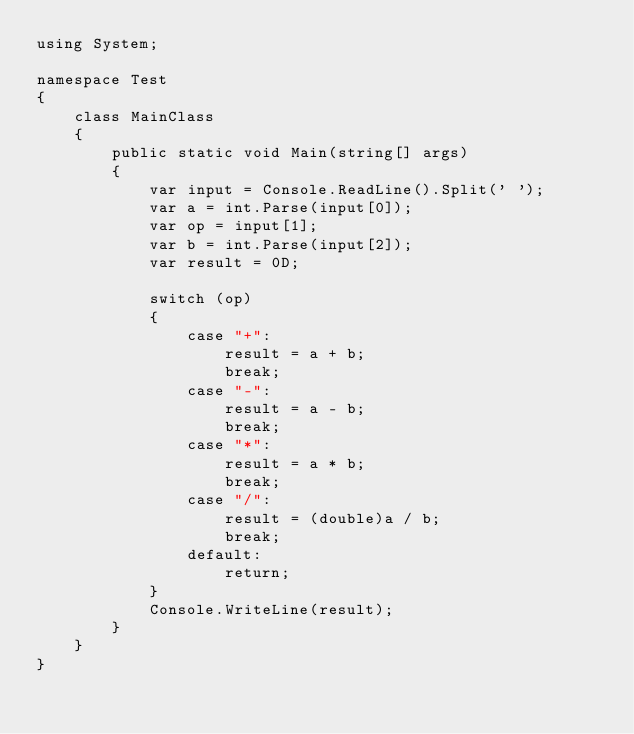<code> <loc_0><loc_0><loc_500><loc_500><_C#_>using System;

namespace Test
{
    class MainClass
    {
        public static void Main(string[] args)
        {
            var input = Console.ReadLine().Split(' ');
            var a = int.Parse(input[0]);
            var op = input[1];
            var b = int.Parse(input[2]);
            var result = 0D;

            switch (op)
            {
                case "+":
                    result = a + b;
                    break;
                case "-":
                    result = a - b;
                    break;
                case "*":
                    result = a * b;
                    break;
                case "/":
                    result = (double)a / b;
                    break;
                default:
                    return;
            }
            Console.WriteLine(result);
        }
    }
}</code> 